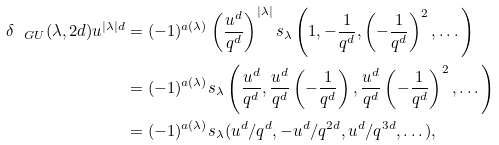<formula> <loc_0><loc_0><loc_500><loc_500>\delta _ { \ G U } ( \lambda , 2 d ) u ^ { | \lambda | d } & = ( - 1 ) ^ { a ( \lambda ) } \left ( \frac { u ^ { d } } { q ^ { d } } \right ) ^ { | \lambda | } s _ { \lambda } \left ( 1 , - \frac { 1 } { q ^ { d } } , \left ( - \frac { 1 } { q ^ { d } } \right ) ^ { 2 } , \dots \right ) \\ & = ( - 1 ) ^ { a ( \lambda ) } s _ { \lambda } \left ( \frac { u ^ { d } } { q ^ { d } } , \frac { u ^ { d } } { q ^ { d } } \left ( - \frac { 1 } { q ^ { d } } \right ) , \frac { u ^ { d } } { q ^ { d } } \left ( - \frac { 1 } { q ^ { d } } \right ) ^ { 2 } , \dots \right ) \\ & = ( - 1 ) ^ { a ( \lambda ) } s _ { \lambda } ( u ^ { d } / q ^ { d } , - u ^ { d } / q ^ { 2 d } , u ^ { d } / q ^ { 3 d } , \dots ) ,</formula> 